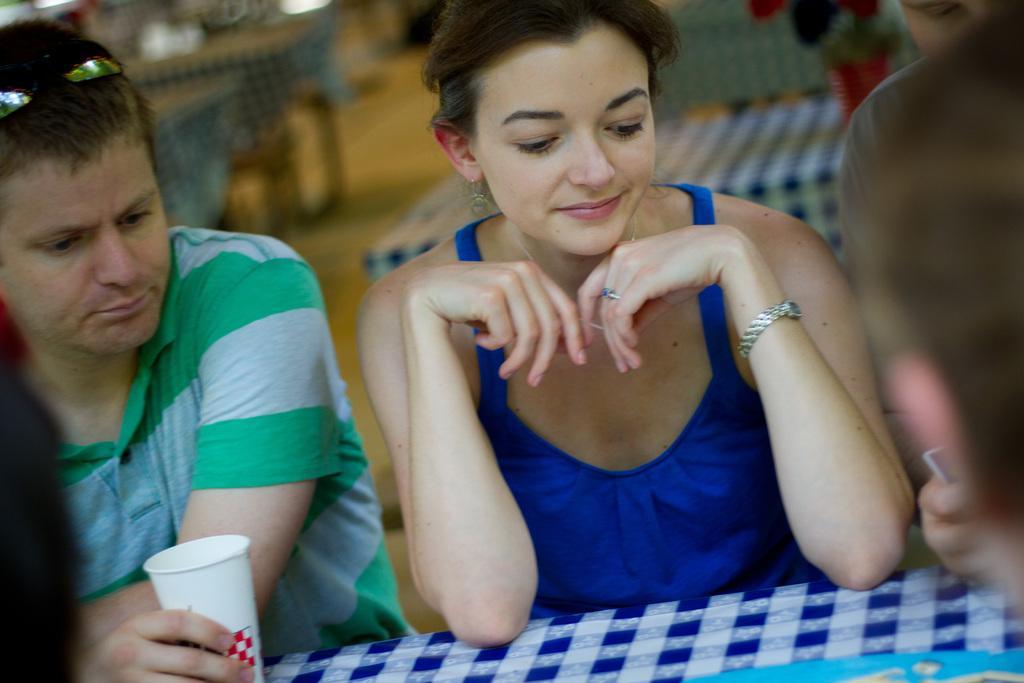Could you give a brief overview of what you see in this image? Here I can see few people looking at the object which is placed on the table. This table is covered with a cloth. The man who is on the left side is holding a glass in the hand. In the background there are some more tables placed on the floor. The background is blurred. 